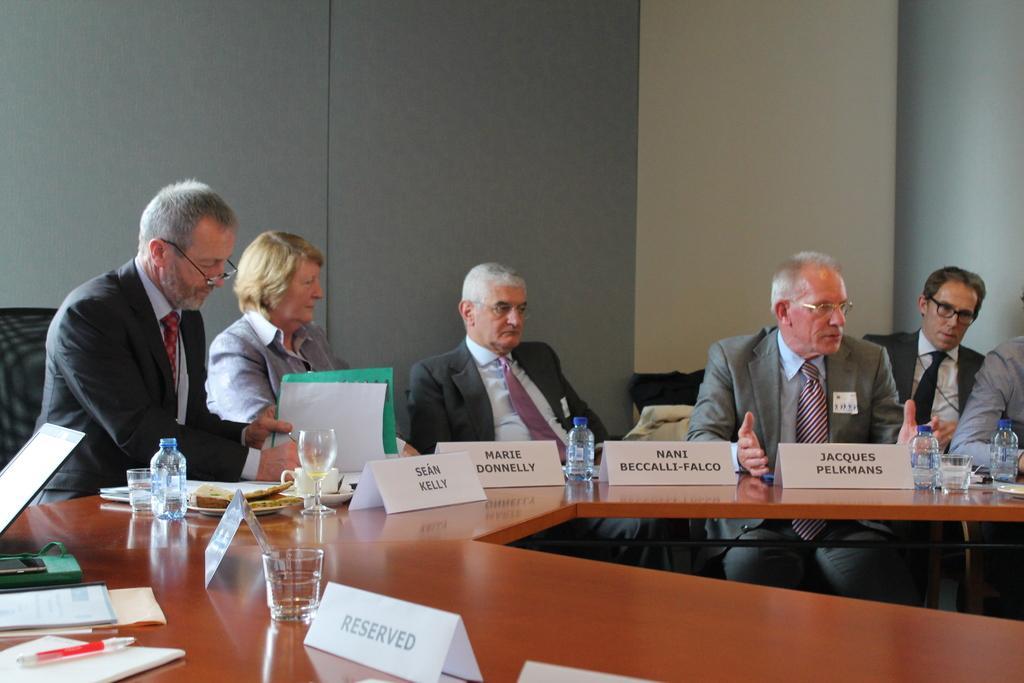Please provide a concise description of this image. In this picture there is a person sitting on the chair and they have a table in front of them with some name boards, water bottles, water glasses, food served in plates, cup and saucer, there is a book and laptop and in the background there is a wall 